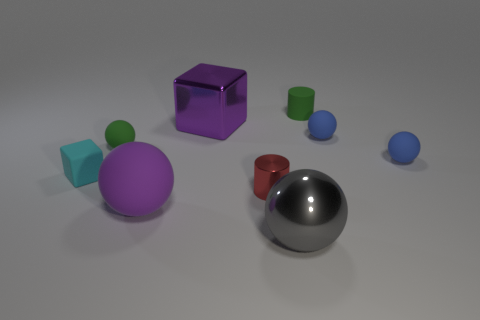Subtract all green spheres. How many spheres are left? 4 Subtract all gray balls. How many balls are left? 4 Subtract all cyan balls. Subtract all gray cubes. How many balls are left? 5 Add 1 gray metallic spheres. How many objects exist? 10 Subtract all cylinders. How many objects are left? 7 Add 8 gray spheres. How many gray spheres exist? 9 Subtract 2 blue balls. How many objects are left? 7 Subtract all small blue things. Subtract all cylinders. How many objects are left? 5 Add 4 metal balls. How many metal balls are left? 5 